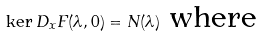Convert formula to latex. <formula><loc_0><loc_0><loc_500><loc_500>\ker D _ { x } F ( \lambda , 0 ) = N ( \lambda ) \text { where}</formula> 